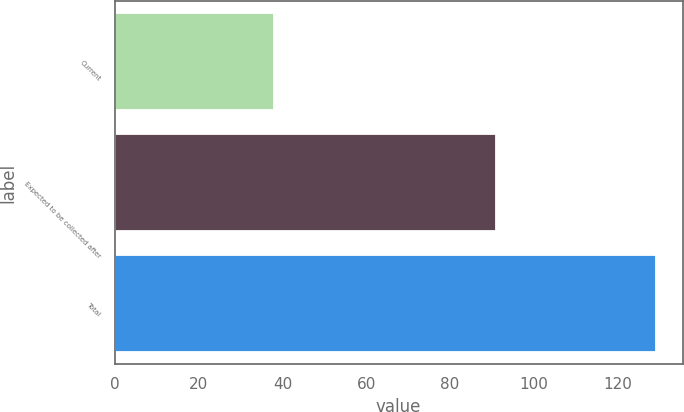<chart> <loc_0><loc_0><loc_500><loc_500><bar_chart><fcel>Current<fcel>Expected to be collected after<fcel>Total<nl><fcel>38<fcel>91<fcel>129<nl></chart> 